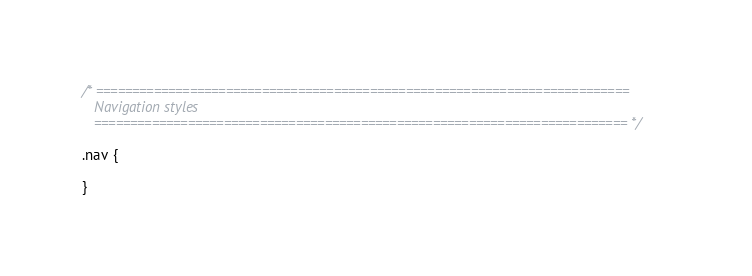<code> <loc_0><loc_0><loc_500><loc_500><_CSS_>/* ==========================================================================
   Navigation styles
   ========================================================================== */

.nav {

}
</code> 